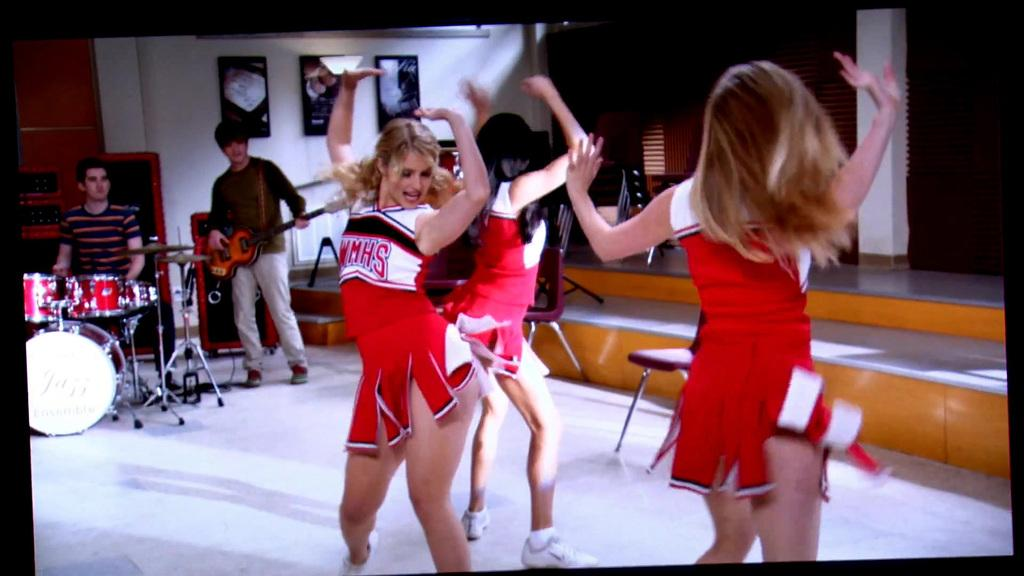<image>
Render a clear and concise summary of the photo. WMHS cheerleaders dance in an auditorium with a drummer and a guitarist in the background. 